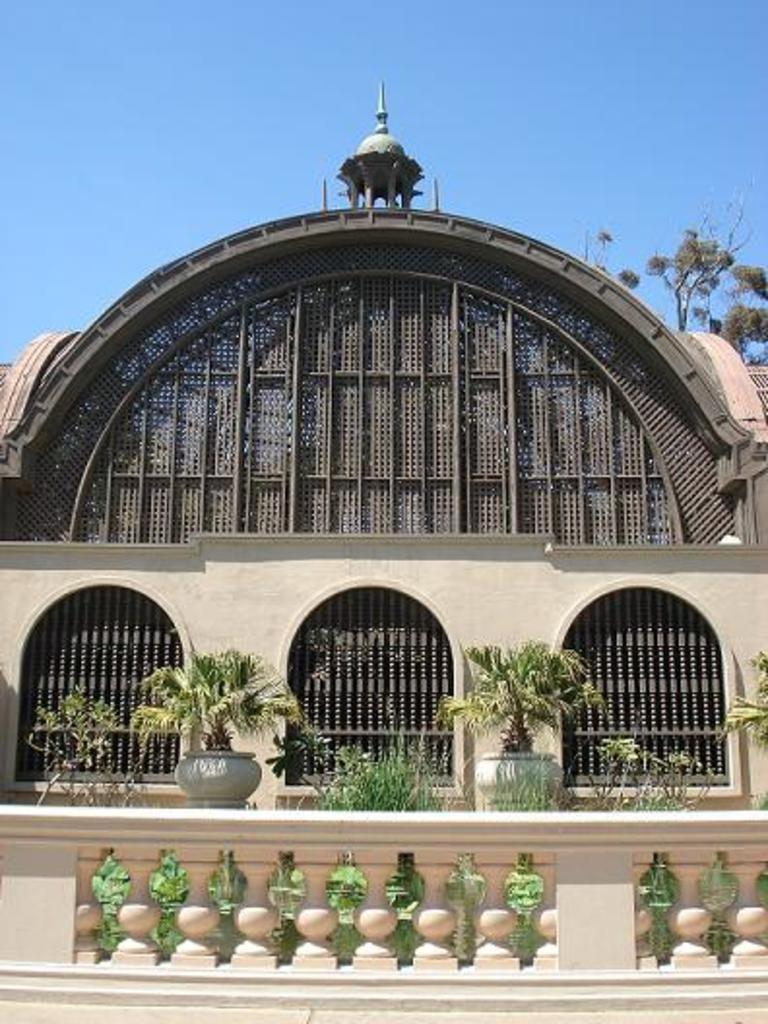What type of structure is present in the image? There is a building in the image. What objects can be seen near the building? There are flower pots and a tree in the image. What can be seen in the background of the image? The sky is visible in the background of the image. How does the taste of the pollution affect the friend in the image? There is no mention of pollution or a friend in the image; the image only features a building, flower pots, a tree, and the sky. 